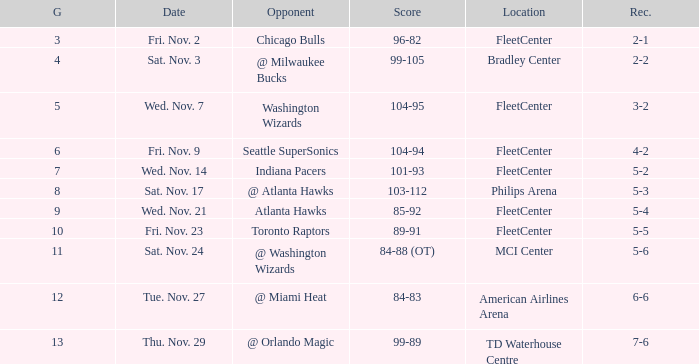On what date did Fleetcenter have a game lower than 9 with a score of 104-94? Fri. Nov. 9. 